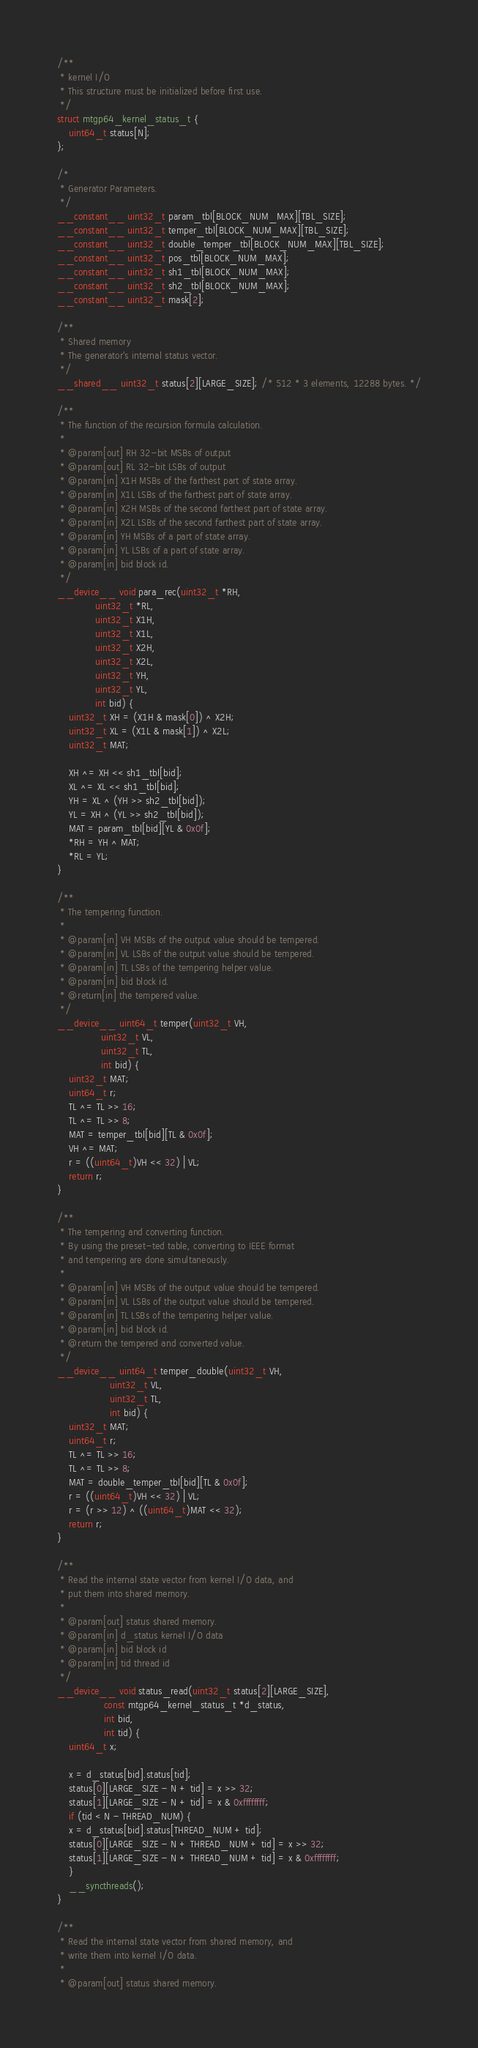Convert code to text. <code><loc_0><loc_0><loc_500><loc_500><_Cuda_>/**
 * kernel I/O
 * This structure must be initialized before first use.
 */
struct mtgp64_kernel_status_t {
    uint64_t status[N];
};

/*
 * Generator Parameters.
 */
__constant__ uint32_t param_tbl[BLOCK_NUM_MAX][TBL_SIZE];
__constant__ uint32_t temper_tbl[BLOCK_NUM_MAX][TBL_SIZE];
__constant__ uint32_t double_temper_tbl[BLOCK_NUM_MAX][TBL_SIZE];
__constant__ uint32_t pos_tbl[BLOCK_NUM_MAX];
__constant__ uint32_t sh1_tbl[BLOCK_NUM_MAX];
__constant__ uint32_t sh2_tbl[BLOCK_NUM_MAX];
__constant__ uint32_t mask[2];

/**
 * Shared memory
 * The generator's internal status vector.
 */
__shared__ uint32_t status[2][LARGE_SIZE]; /* 512 * 3 elements, 12288 bytes. */

/**
 * The function of the recursion formula calculation.
 *
 * @param[out] RH 32-bit MSBs of output
 * @param[out] RL 32-bit LSBs of output
 * @param[in] X1H MSBs of the farthest part of state array.
 * @param[in] X1L LSBs of the farthest part of state array.
 * @param[in] X2H MSBs of the second farthest part of state array.
 * @param[in] X2L LSBs of the second farthest part of state array.
 * @param[in] YH MSBs of a part of state array.
 * @param[in] YL LSBs of a part of state array.
 * @param[in] bid block id.
 */
__device__ void para_rec(uint32_t *RH,
			 uint32_t *RL,
			 uint32_t X1H,
			 uint32_t X1L,
			 uint32_t X2H,
			 uint32_t X2L,
			 uint32_t YH,
			 uint32_t YL,
			 int bid) {
    uint32_t XH = (X1H & mask[0]) ^ X2H;
    uint32_t XL = (X1L & mask[1]) ^ X2L;
    uint32_t MAT;

    XH ^= XH << sh1_tbl[bid];
    XL ^= XL << sh1_tbl[bid];
    YH = XL ^ (YH >> sh2_tbl[bid]);
    YL = XH ^ (YL >> sh2_tbl[bid]);
    MAT = param_tbl[bid][YL & 0x0f];
    *RH = YH ^ MAT;
    *RL = YL;
}

/**
 * The tempering function.
 *
 * @param[in] VH MSBs of the output value should be tempered.
 * @param[in] VL LSBs of the output value should be tempered.
 * @param[in] TL LSBs of the tempering helper value.
 * @param[in] bid block id.
 * @return[in] the tempered value.
 */
__device__ uint64_t temper(uint32_t VH,
			   uint32_t VL,
			   uint32_t TL,
			   int bid) {
    uint32_t MAT;
    uint64_t r;
    TL ^= TL >> 16;
    TL ^= TL >> 8;
    MAT = temper_tbl[bid][TL & 0x0f];
    VH ^= MAT;
    r = ((uint64_t)VH << 32) | VL;
    return r;
}

/**
 * The tempering and converting function.
 * By using the preset-ted table, converting to IEEE format
 * and tempering are done simultaneously.
 *
 * @param[in] VH MSBs of the output value should be tempered.
 * @param[in] VL LSBs of the output value should be tempered.
 * @param[in] TL LSBs of the tempering helper value.
 * @param[in] bid block id.
 * @return the tempered and converted value.
 */
__device__ uint64_t temper_double(uint32_t VH,
				  uint32_t VL,
				  uint32_t TL,
				  int bid) {
    uint32_t MAT;
    uint64_t r;
    TL ^= TL >> 16;
    TL ^= TL >> 8;
    MAT = double_temper_tbl[bid][TL & 0x0f];
    r = ((uint64_t)VH << 32) | VL;
    r = (r >> 12) ^ ((uint64_t)MAT << 32);
    return r;
}

/**
 * Read the internal state vector from kernel I/O data, and
 * put them into shared memory.
 *
 * @param[out] status shared memory.
 * @param[in] d_status kernel I/O data
 * @param[in] bid block id
 * @param[in] tid thread id
 */
__device__ void status_read(uint32_t status[2][LARGE_SIZE],
			    const mtgp64_kernel_status_t *d_status,
			    int bid,
			    int tid) {
    uint64_t x;

    x = d_status[bid].status[tid];
    status[0][LARGE_SIZE - N + tid] = x >> 32;
    status[1][LARGE_SIZE - N + tid] = x & 0xffffffff;
    if (tid < N - THREAD_NUM) {
	x = d_status[bid].status[THREAD_NUM + tid];
	status[0][LARGE_SIZE - N + THREAD_NUM + tid] = x >> 32;
	status[1][LARGE_SIZE - N + THREAD_NUM + tid] = x & 0xffffffff;
    }
    __syncthreads();
}

/**
 * Read the internal state vector from shared memory, and
 * write them into kernel I/O data.
 *
 * @param[out] status shared memory.</code> 